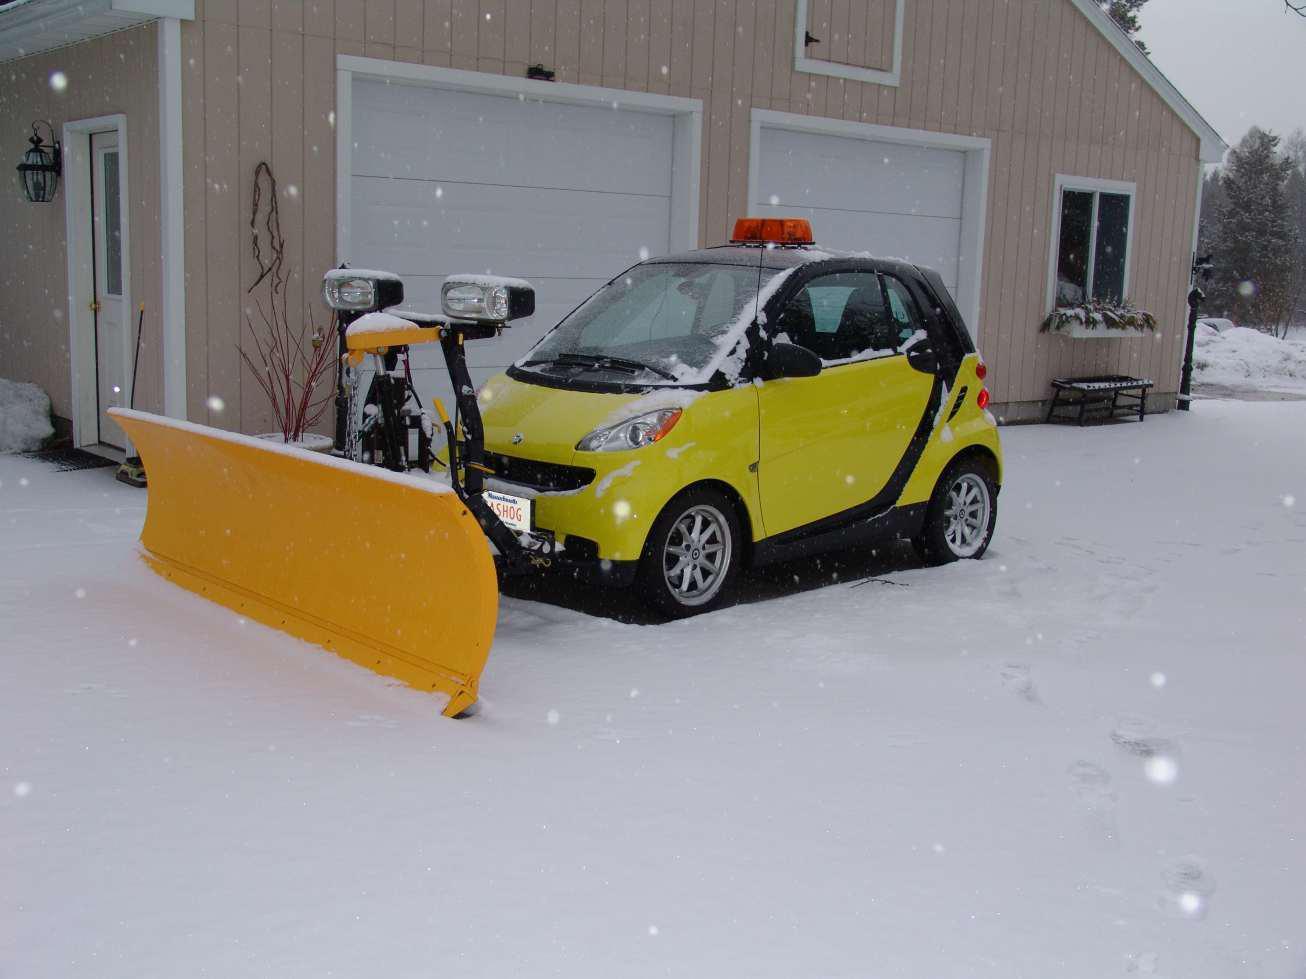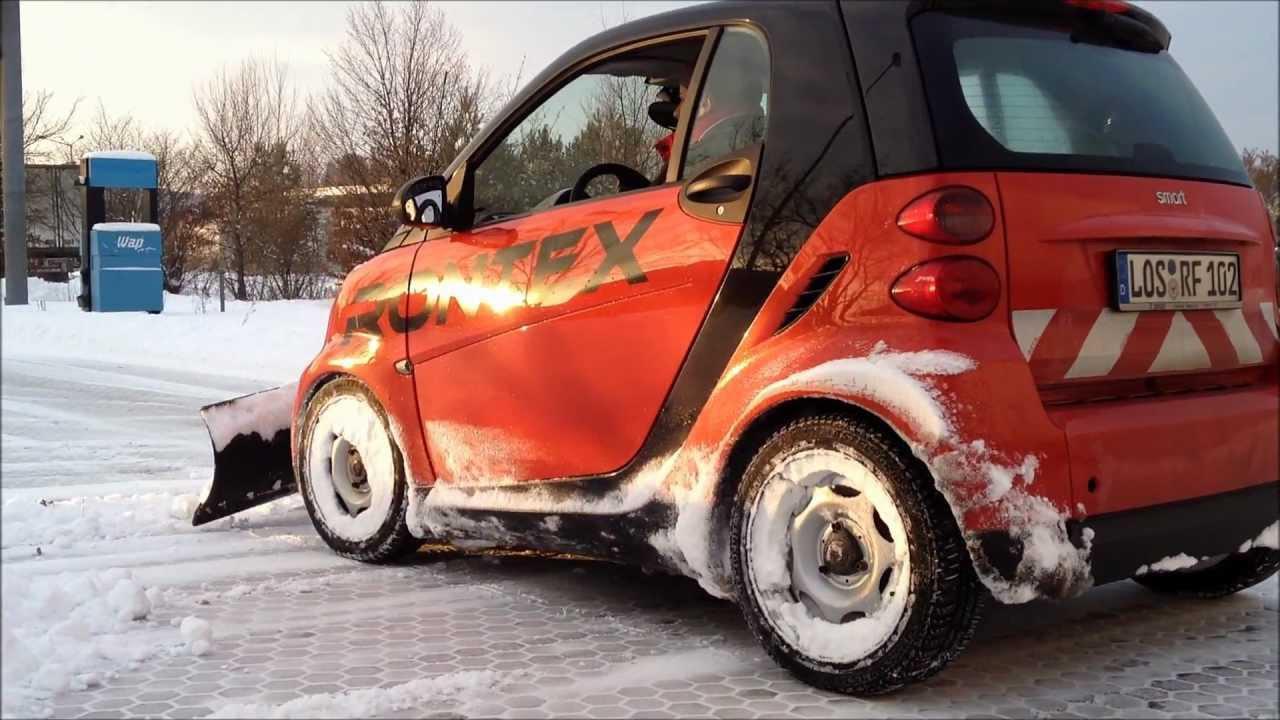The first image is the image on the left, the second image is the image on the right. Evaluate the accuracy of this statement regarding the images: "there is a yellow smart car with a plow blade on the front". Is it true? Answer yes or no. Yes. The first image is the image on the left, the second image is the image on the right. For the images displayed, is the sentence "An image shows a smart-car shaped orange vehicle with a plow attachment." factually correct? Answer yes or no. Yes. 